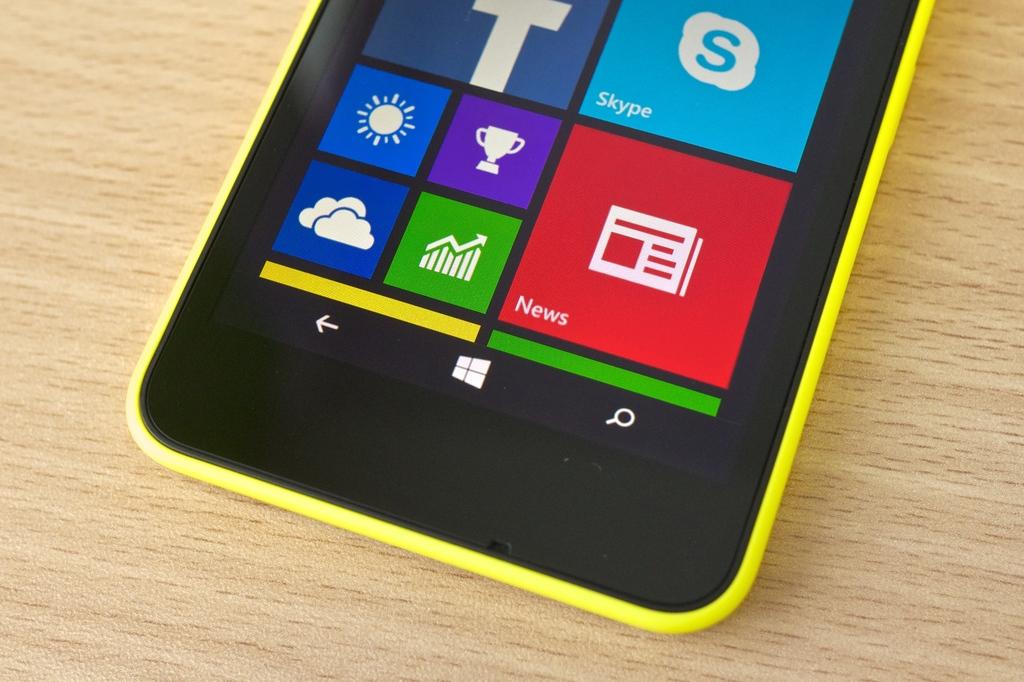What app is shown on the phone?
Your response must be concise. Skype. What is the text in the red square on the bottom?
Keep it short and to the point. News. 